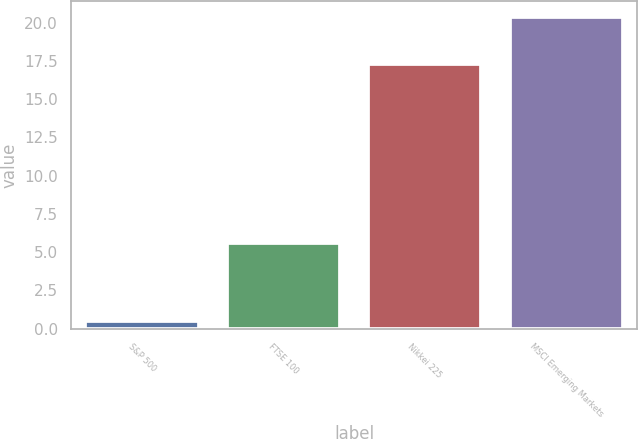Convert chart to OTSL. <chart><loc_0><loc_0><loc_500><loc_500><bar_chart><fcel>S&P 500<fcel>FTSE 100<fcel>Nikkei 225<fcel>MSCI Emerging Markets<nl><fcel>0.5<fcel>5.6<fcel>17.3<fcel>20.4<nl></chart> 